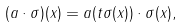<formula> <loc_0><loc_0><loc_500><loc_500>( a \cdot \sigma ) ( x ) = a ( t \sigma ( x ) ) \cdot \sigma ( x ) ,</formula> 